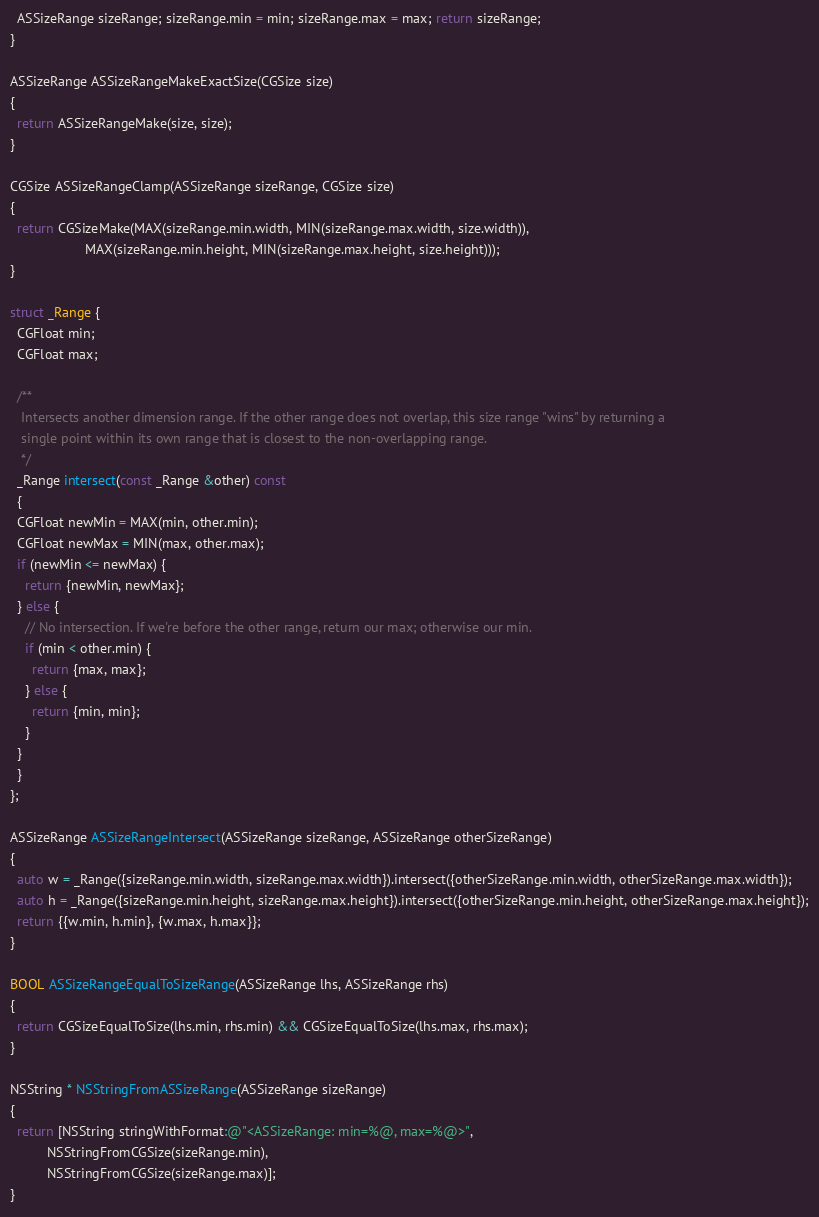Convert code to text. <code><loc_0><loc_0><loc_500><loc_500><_ObjectiveC_>  ASSizeRange sizeRange; sizeRange.min = min; sizeRange.max = max; return sizeRange;
}

ASSizeRange ASSizeRangeMakeExactSize(CGSize size)
{
  return ASSizeRangeMake(size, size);
}

CGSize ASSizeRangeClamp(ASSizeRange sizeRange, CGSize size)
{
  return CGSizeMake(MAX(sizeRange.min.width, MIN(sizeRange.max.width, size.width)),
                    MAX(sizeRange.min.height, MIN(sizeRange.max.height, size.height)));
}

struct _Range {
  CGFloat min;
  CGFloat max;
  
  /**
   Intersects another dimension range. If the other range does not overlap, this size range "wins" by returning a
   single point within its own range that is closest to the non-overlapping range.
   */
  _Range intersect(const _Range &other) const
  {
  CGFloat newMin = MAX(min, other.min);
  CGFloat newMax = MIN(max, other.max);
  if (newMin <= newMax) {
    return {newMin, newMax};
  } else {
    // No intersection. If we're before the other range, return our max; otherwise our min.
    if (min < other.min) {
      return {max, max};
    } else {
      return {min, min};
    }
  }
  }
};

ASSizeRange ASSizeRangeIntersect(ASSizeRange sizeRange, ASSizeRange otherSizeRange)
{
  auto w = _Range({sizeRange.min.width, sizeRange.max.width}).intersect({otherSizeRange.min.width, otherSizeRange.max.width});
  auto h = _Range({sizeRange.min.height, sizeRange.max.height}).intersect({otherSizeRange.min.height, otherSizeRange.max.height});
  return {{w.min, h.min}, {w.max, h.max}};
}

BOOL ASSizeRangeEqualToSizeRange(ASSizeRange lhs, ASSizeRange rhs)
{
  return CGSizeEqualToSize(lhs.min, rhs.min) && CGSizeEqualToSize(lhs.max, rhs.max);
}

NSString * NSStringFromASSizeRange(ASSizeRange sizeRange)
{
  return [NSString stringWithFormat:@"<ASSizeRange: min=%@, max=%@>",
          NSStringFromCGSize(sizeRange.min),
          NSStringFromCGSize(sizeRange.max)];
}
</code> 